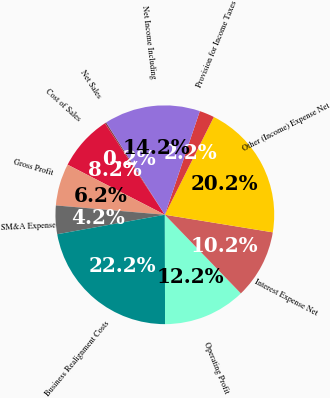Convert chart. <chart><loc_0><loc_0><loc_500><loc_500><pie_chart><fcel>Net Sales<fcel>Cost of Sales<fcel>Gross Profit<fcel>SM&A Expense<fcel>Business Realignment Costs<fcel>Operating Profit<fcel>Interest Expense Net<fcel>Other (Income) Expense Net<fcel>Provision for Income Taxes<fcel>Net Income Including<nl><fcel>0.22%<fcel>8.2%<fcel>6.21%<fcel>4.21%<fcel>22.18%<fcel>12.2%<fcel>10.2%<fcel>20.18%<fcel>2.21%<fcel>14.19%<nl></chart> 